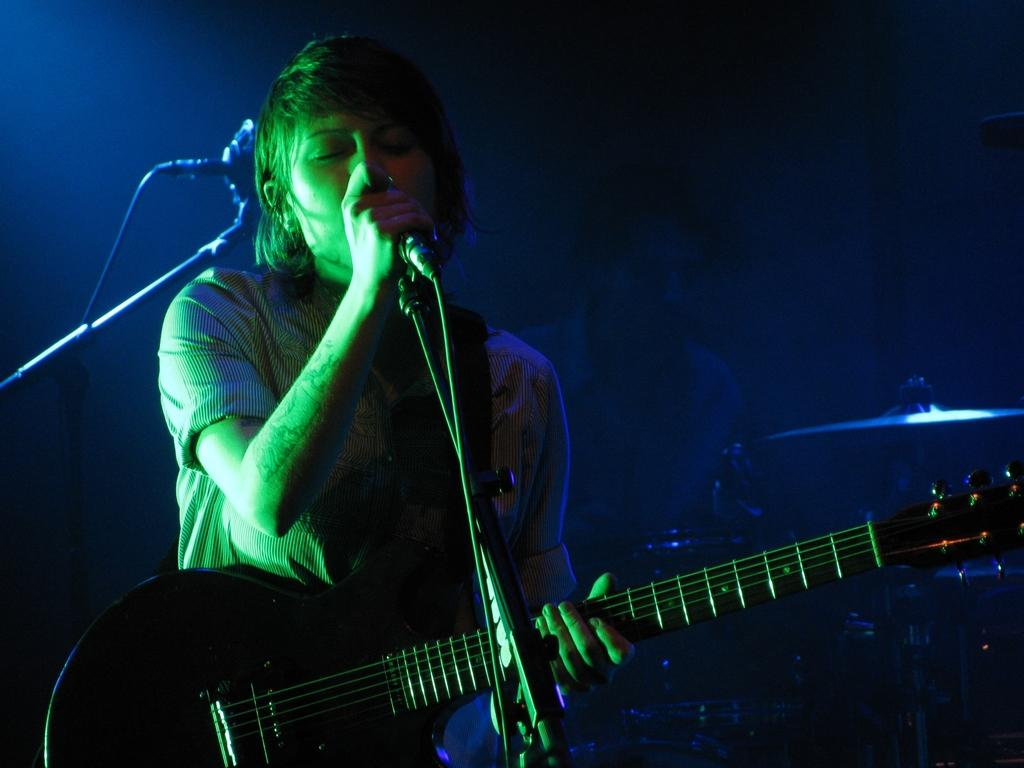What is the lady in the image doing? The lady in the image is singing and playing a guitar. What instrument is the person in the image playing? The person in the image is playing drums. What object is the lady holding in the image? The lady is holding a microphone. Can you see another microphone in the image? Yes, there is another microphone on the left side of the image. How does the lady help the beetle in the image? There is no beetle present in the image, so the lady cannot help a beetle. 